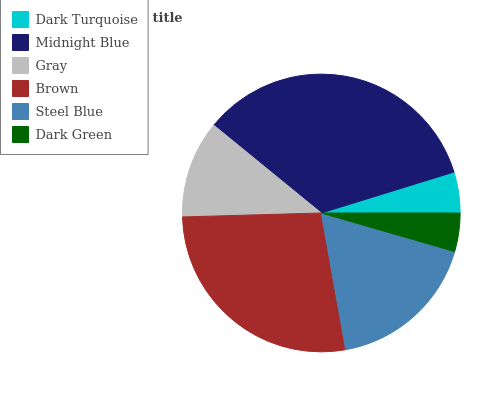Is Dark Green the minimum?
Answer yes or no. Yes. Is Midnight Blue the maximum?
Answer yes or no. Yes. Is Gray the minimum?
Answer yes or no. No. Is Gray the maximum?
Answer yes or no. No. Is Midnight Blue greater than Gray?
Answer yes or no. Yes. Is Gray less than Midnight Blue?
Answer yes or no. Yes. Is Gray greater than Midnight Blue?
Answer yes or no. No. Is Midnight Blue less than Gray?
Answer yes or no. No. Is Steel Blue the high median?
Answer yes or no. Yes. Is Gray the low median?
Answer yes or no. Yes. Is Brown the high median?
Answer yes or no. No. Is Midnight Blue the low median?
Answer yes or no. No. 